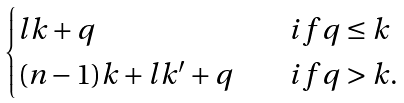<formula> <loc_0><loc_0><loc_500><loc_500>\begin{cases} l k + q \quad & i f q \leq k \\ ( n - 1 ) k + l k ^ { \prime } + q \quad & i f q > k . \end{cases}</formula> 